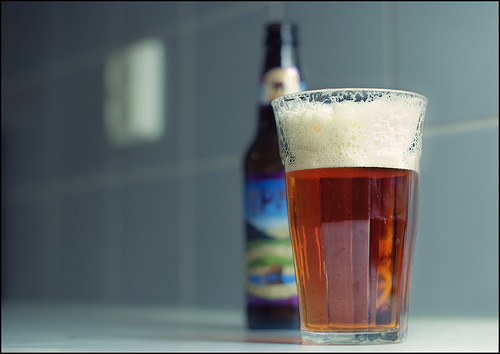<image>
Is the froth behind the beer bottle? No. The froth is not behind the beer bottle. From this viewpoint, the froth appears to be positioned elsewhere in the scene. Where is the bottle in relation to the glass? Is it next to the glass? Yes. The bottle is positioned adjacent to the glass, located nearby in the same general area. Is there a glass in front of the bottle? Yes. The glass is positioned in front of the bottle, appearing closer to the camera viewpoint. 